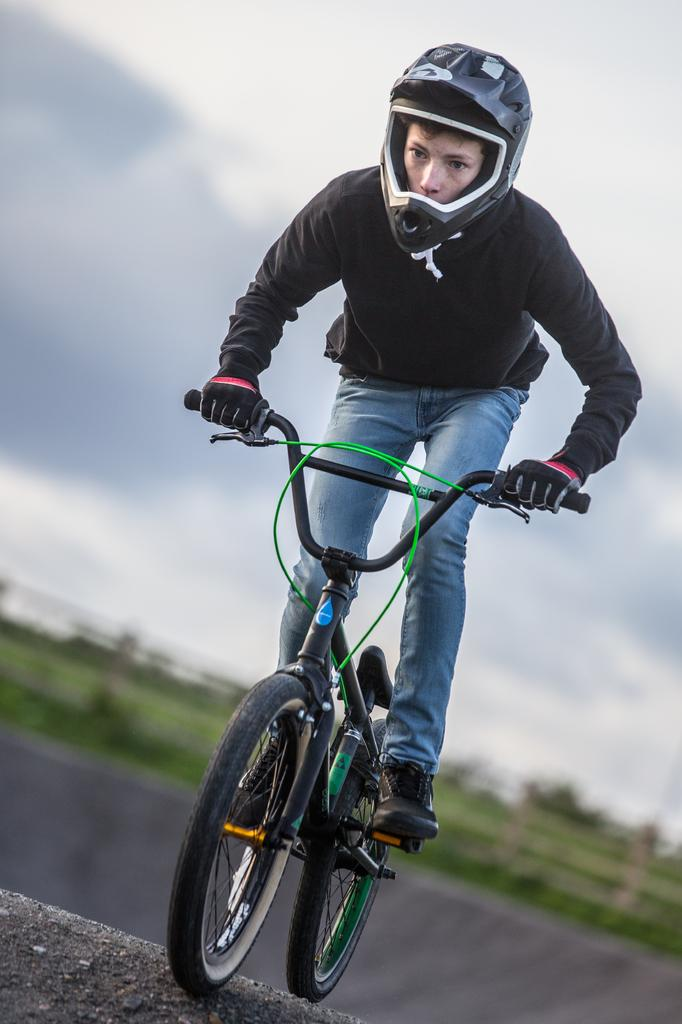What is the person in the image doing? The person is cycling a bicycle in the image. What is the person wearing while cycling? The person is wearing a black color T-shirt and a helmet on their head. What can be seen in the background of the image? There are clouds in the sky in the background of the image. What is the governor's reaction to the person cycling in the image? There is no governor present in the image, so it is not possible to determine their reaction. 